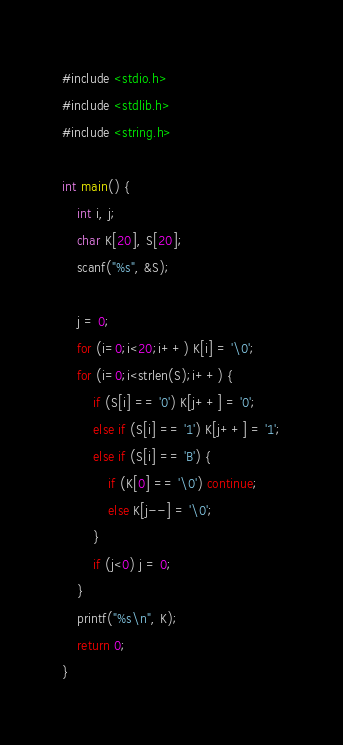<code> <loc_0><loc_0><loc_500><loc_500><_C_>#include <stdio.h>
#include <stdlib.h>
#include <string.h>

int main() {
	int i, j;
	char K[20], S[20];
	scanf("%s", &S);

	j = 0;
	for (i=0;i<20;i++) K[i] = '\0';
	for (i=0;i<strlen(S);i++) {
		if (S[i] == '0') K[j++] = '0';
		else if (S[i] == '1') K[j++] = '1';
		else if (S[i] == 'B') {
			if (K[0] == '\0') continue;
			else K[j--] = '\0';
		}
		if (j<0) j = 0;
	}
	printf("%s\n", K);
	return 0;
}
</code> 